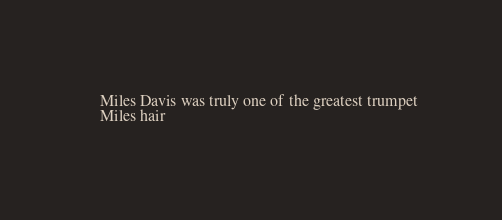<code> <loc_0><loc_0><loc_500><loc_500><_XML_>	  
	 Miles Davis was truly one of the greatest trumpet 
	 Miles hair 
	  
</code> 